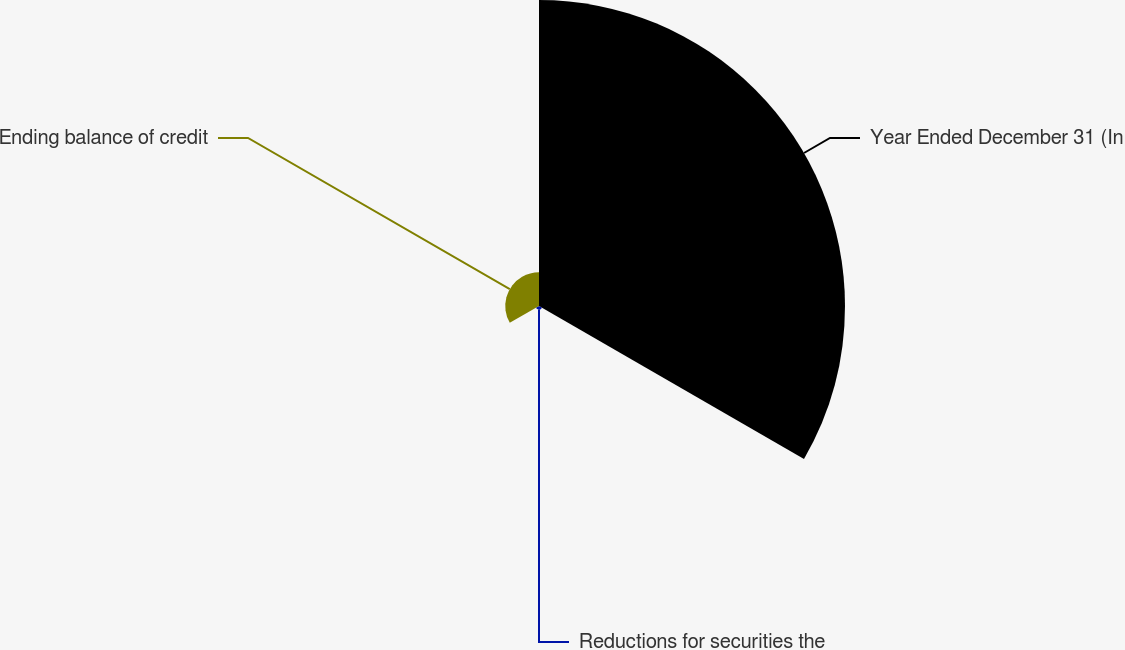<chart> <loc_0><loc_0><loc_500><loc_500><pie_chart><fcel>Year Ended December 31 (In<fcel>Reductions for securities the<fcel>Ending balance of credit<nl><fcel>89.15%<fcel>1.02%<fcel>9.83%<nl></chart> 